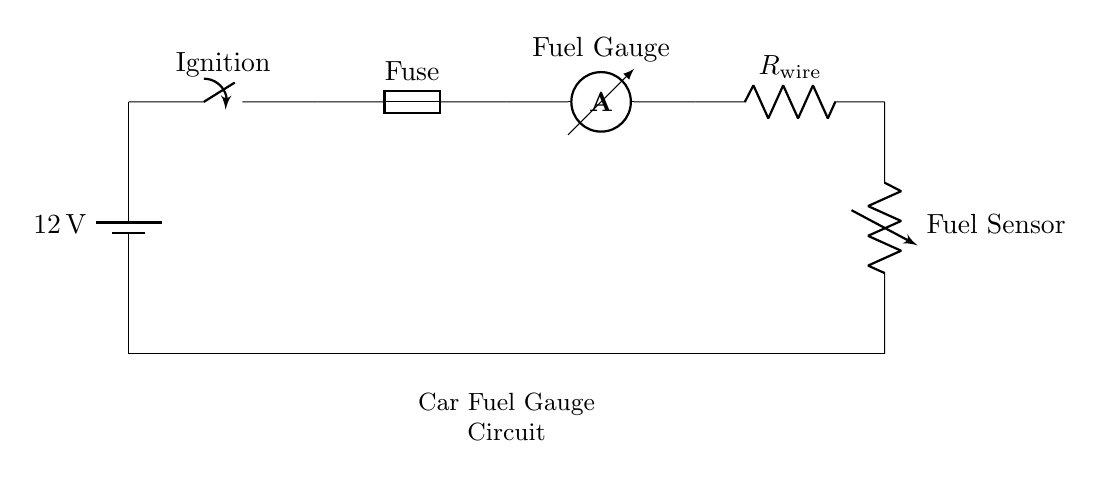What is the voltage of this circuit? The circuit operates at a standard automotive battery voltage of 12 volts, clearly indicated next to the battery symbol.
Answer: 12 volts What component represents the fuel level? The fuel level is represented by a variable resistor labeled as "Fuel Sensor," which measures the varying resistance based on fuel levels.
Answer: Fuel Sensor Which component indicates the fuel level to the driver? The component that indicates the fuel level to the driver is the "Fuel Gauge," which is placed in the circuit to display the current fuel level based on the sensor input.
Answer: Fuel Gauge How many main components are in this circuit? The main components include the battery, ignition switch, fuse, fuel gauge, wiring resistor, and fuel sensor. When counted, there are six significant components.
Answer: Six What role does the fuse serve in this circuit? The fuse acts as a safety device; it protects the circuit by breaking the connection if the current exceeds a safe level, preventing damage to other components.
Answer: Safety device What would happen if the fuel sensor fails? If the fuel sensor fails, it would result in incorrect resistance, potentially leading to a faulty fuel gauge reading, which can mislead the driver about the actual fuel level.
Answer: Faulty fuel gauge reading Is this circuit a series circuit? Yes, the circuit is designed as a series circuit, where current flows through each component sequentially; any disconnection would interrupt the entire circuit.
Answer: Yes 